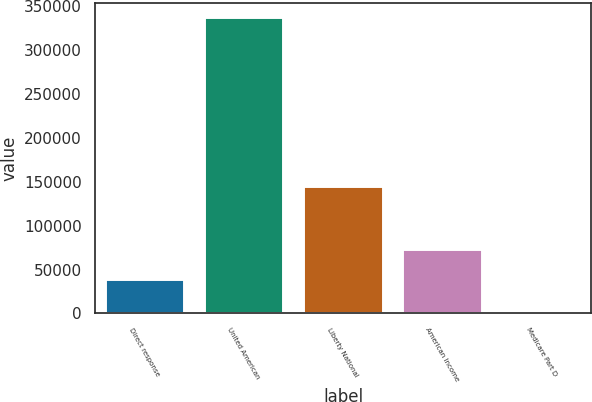Convert chart to OTSL. <chart><loc_0><loc_0><loc_500><loc_500><bar_chart><fcel>Direct response<fcel>United American<fcel>Liberty National<fcel>American Income<fcel>Medicare Part D<nl><fcel>39446<fcel>337175<fcel>145341<fcel>73163.4<fcel>0.87<nl></chart> 